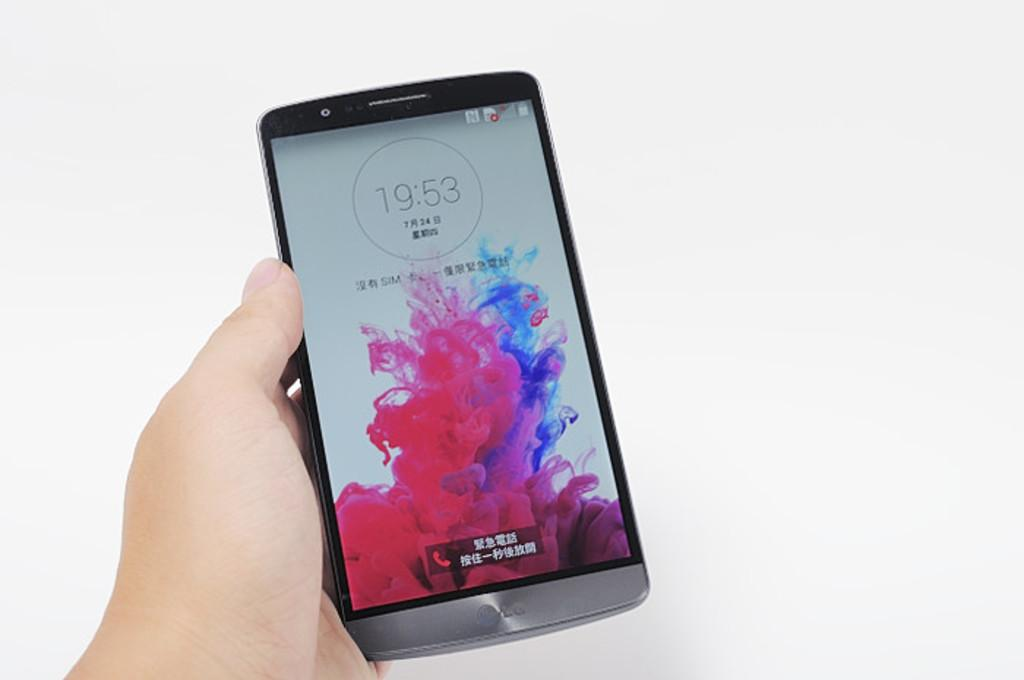<image>
Share a concise interpretation of the image provided. A phone screen shows a time of 19:53 on the home screen. 